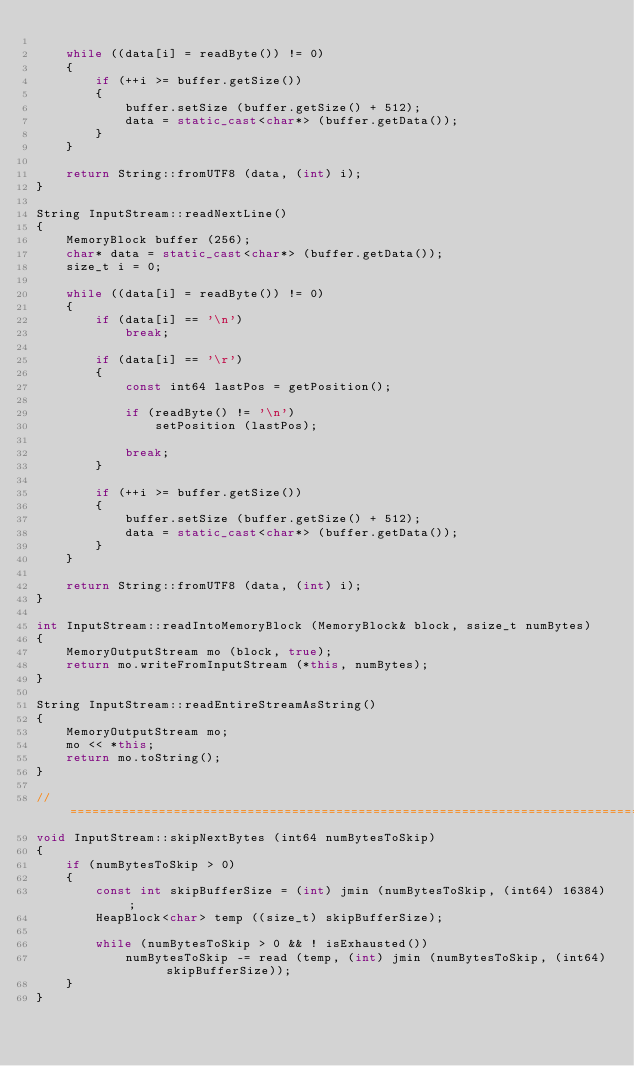<code> <loc_0><loc_0><loc_500><loc_500><_C++_>
    while ((data[i] = readByte()) != 0)
    {
        if (++i >= buffer.getSize())
        {
            buffer.setSize (buffer.getSize() + 512);
            data = static_cast<char*> (buffer.getData());
        }
    }

    return String::fromUTF8 (data, (int) i);
}

String InputStream::readNextLine()
{
    MemoryBlock buffer (256);
    char* data = static_cast<char*> (buffer.getData());
    size_t i = 0;

    while ((data[i] = readByte()) != 0)
    {
        if (data[i] == '\n')
            break;

        if (data[i] == '\r')
        {
            const int64 lastPos = getPosition();

            if (readByte() != '\n')
                setPosition (lastPos);

            break;
        }

        if (++i >= buffer.getSize())
        {
            buffer.setSize (buffer.getSize() + 512);
            data = static_cast<char*> (buffer.getData());
        }
    }

    return String::fromUTF8 (data, (int) i);
}

int InputStream::readIntoMemoryBlock (MemoryBlock& block, ssize_t numBytes)
{
    MemoryOutputStream mo (block, true);
    return mo.writeFromInputStream (*this, numBytes);
}

String InputStream::readEntireStreamAsString()
{
    MemoryOutputStream mo;
    mo << *this;
    return mo.toString();
}

//==============================================================================
void InputStream::skipNextBytes (int64 numBytesToSkip)
{
    if (numBytesToSkip > 0)
    {
        const int skipBufferSize = (int) jmin (numBytesToSkip, (int64) 16384);
        HeapBlock<char> temp ((size_t) skipBufferSize);

        while (numBytesToSkip > 0 && ! isExhausted())
            numBytesToSkip -= read (temp, (int) jmin (numBytesToSkip, (int64) skipBufferSize));
    }
}
</code> 